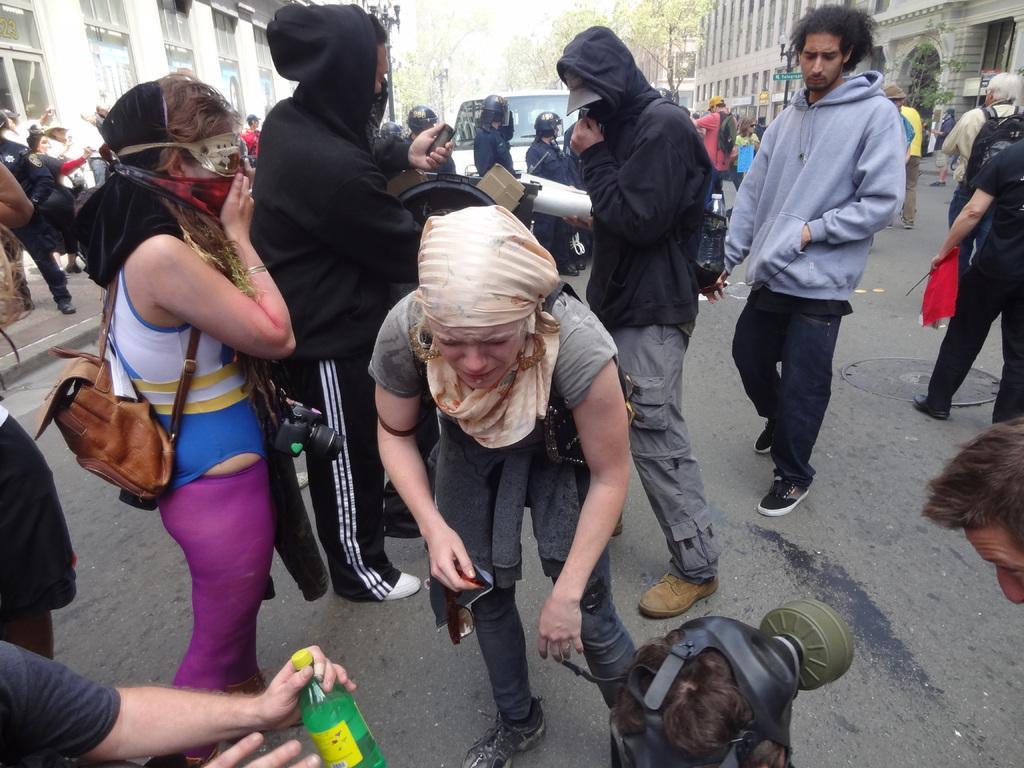How would you summarize this image in a sentence or two? In this image I can see people standing on the road. In the background I can see a vehicle, poles, and buildings. I can also see trees. 